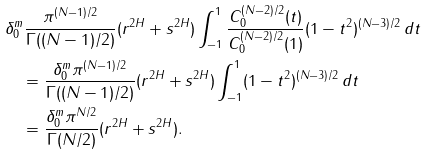<formula> <loc_0><loc_0><loc_500><loc_500>& \delta ^ { m } _ { 0 } \frac { \pi ^ { ( N - 1 ) / 2 } } { \Gamma ( ( N - 1 ) / 2 ) } ( r ^ { 2 H } + s ^ { 2 H } ) \int ^ { 1 } _ { - 1 } \frac { C ^ { ( N - 2 ) / 2 } _ { 0 } ( t ) } { C ^ { ( N - 2 ) / 2 } _ { 0 } ( 1 ) } ( 1 - t ^ { 2 } ) ^ { ( N - 3 ) / 2 } \, d t \\ & \quad = \frac { \delta ^ { m } _ { 0 } \pi ^ { ( N - 1 ) / 2 } } { \Gamma ( ( N - 1 ) / 2 ) } ( r ^ { 2 H } + s ^ { 2 H } ) \int ^ { 1 } _ { - 1 } ( 1 - t ^ { 2 } ) ^ { ( N - 3 ) / 2 } \, d t \\ & \quad = \frac { \delta ^ { m } _ { 0 } \pi ^ { N / 2 } } { \Gamma ( N / 2 ) } ( r ^ { 2 H } + s ^ { 2 H } ) .</formula> 